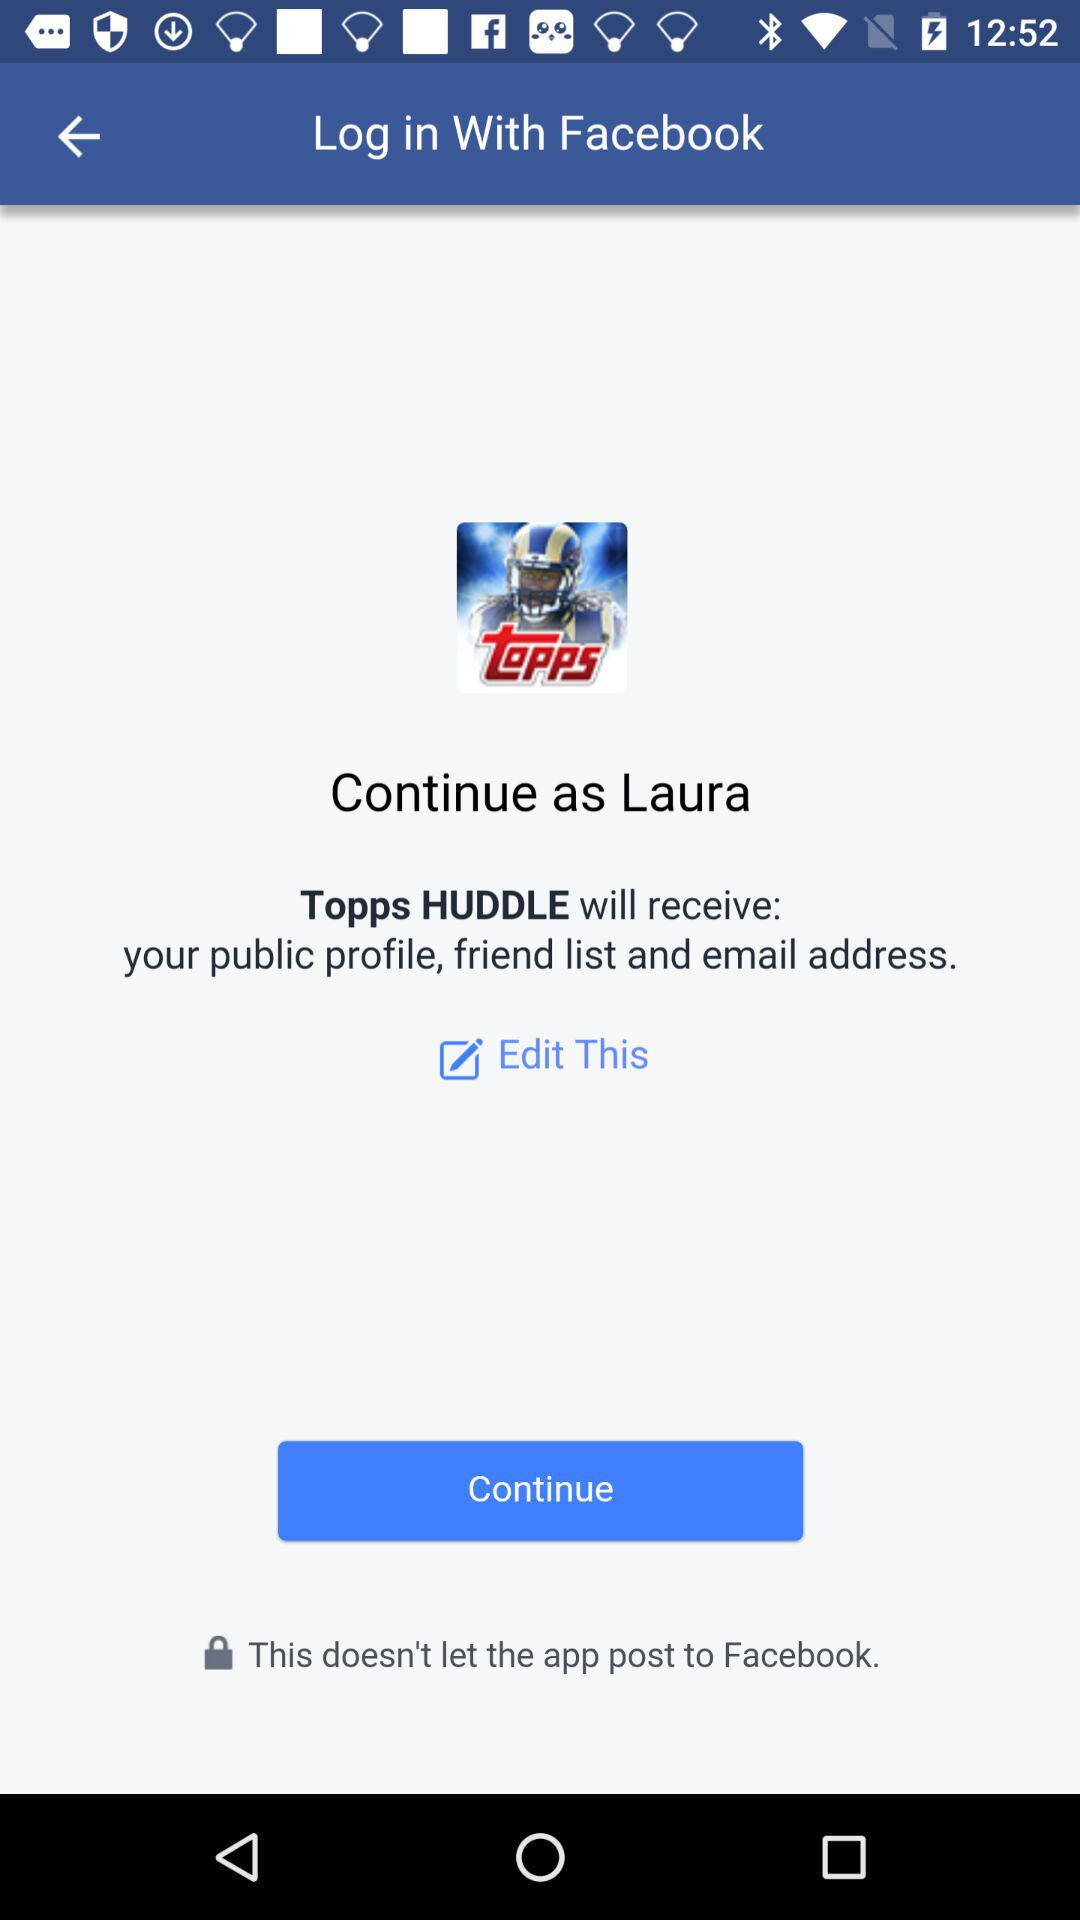What application can be used to log in? The application that can be used to log in is "Facebook". 